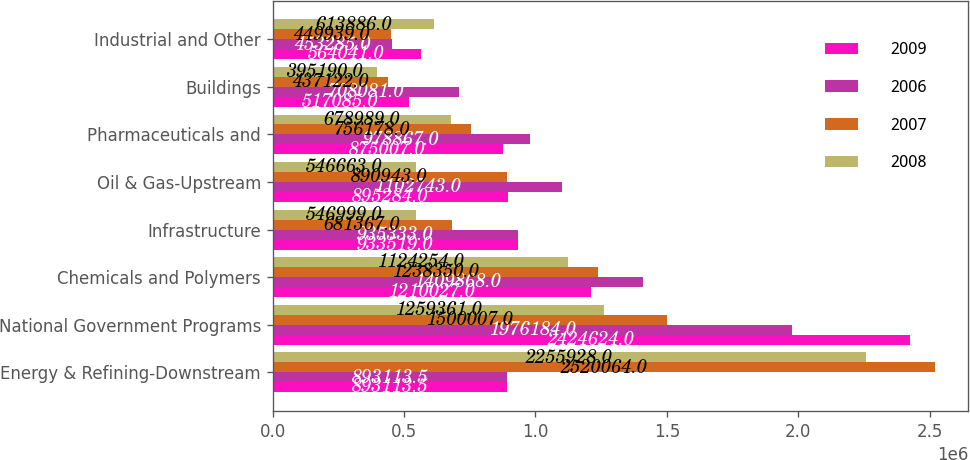Convert chart. <chart><loc_0><loc_0><loc_500><loc_500><stacked_bar_chart><ecel><fcel>Energy & Refining-Downstream<fcel>National Government Programs<fcel>Chemicals and Polymers<fcel>Infrastructure<fcel>Oil & Gas-Upstream<fcel>Pharmaceuticals and<fcel>Buildings<fcel>Industrial and Other<nl><fcel>2009<fcel>893114<fcel>2.42462e+06<fcel>1.21003e+06<fcel>933519<fcel>895284<fcel>875007<fcel>517085<fcel>564041<nl><fcel>2006<fcel>893114<fcel>1.97618e+06<fcel>1.40987e+06<fcel>935333<fcel>1.10274e+06<fcel>978867<fcel>708081<fcel>453285<nl><fcel>2007<fcel>2.52006e+06<fcel>1.50001e+06<fcel>1.23835e+06<fcel>681367<fcel>890943<fcel>756178<fcel>437122<fcel>449939<nl><fcel>2008<fcel>2.25593e+06<fcel>1.25936e+06<fcel>1.12425e+06<fcel>546999<fcel>546663<fcel>678989<fcel>395190<fcel>613886<nl></chart> 